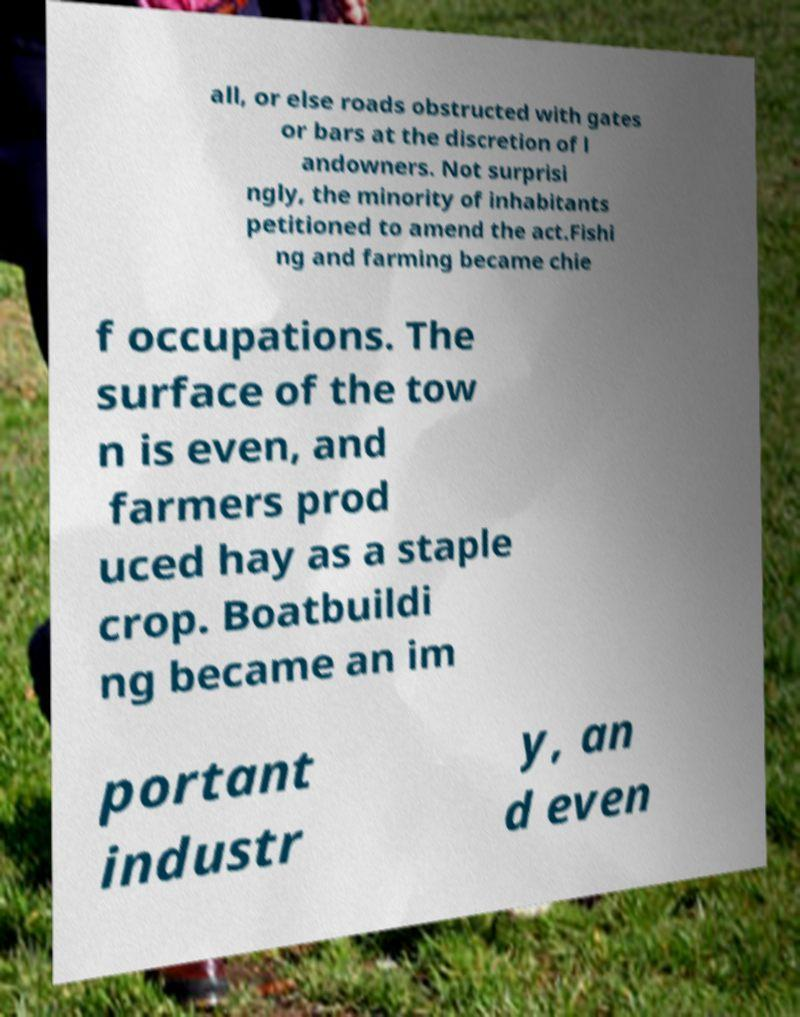For documentation purposes, I need the text within this image transcribed. Could you provide that? all, or else roads obstructed with gates or bars at the discretion of l andowners. Not surprisi ngly, the minority of inhabitants petitioned to amend the act.Fishi ng and farming became chie f occupations. The surface of the tow n is even, and farmers prod uced hay as a staple crop. Boatbuildi ng became an im portant industr y, an d even 